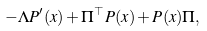<formula> <loc_0><loc_0><loc_500><loc_500>- \Lambda P ^ { \prime } ( x ) + \Pi ^ { \top } P ( x ) + P ( x ) \Pi ,</formula> 